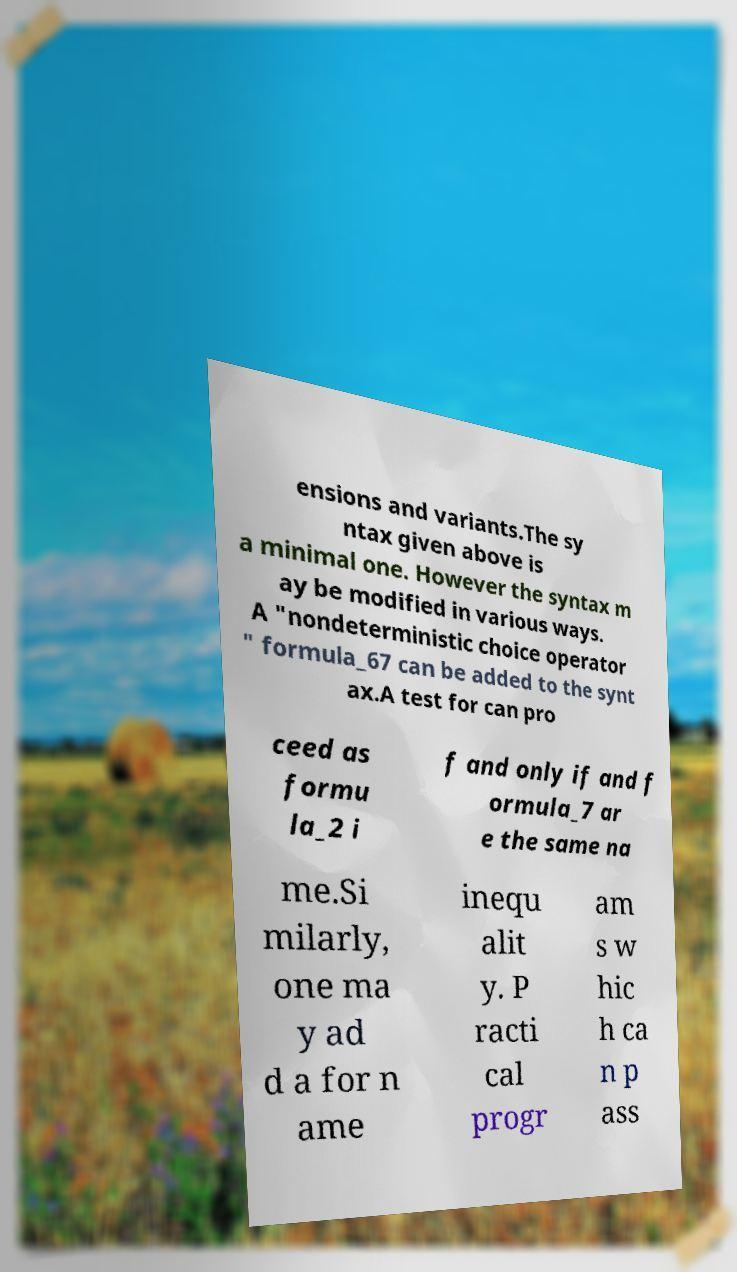I need the written content from this picture converted into text. Can you do that? ensions and variants.The sy ntax given above is a minimal one. However the syntax m ay be modified in various ways. A "nondeterministic choice operator " formula_67 can be added to the synt ax.A test for can pro ceed as formu la_2 i f and only if and f ormula_7 ar e the same na me.Si milarly, one ma y ad d a for n ame inequ alit y. P racti cal progr am s w hic h ca n p ass 